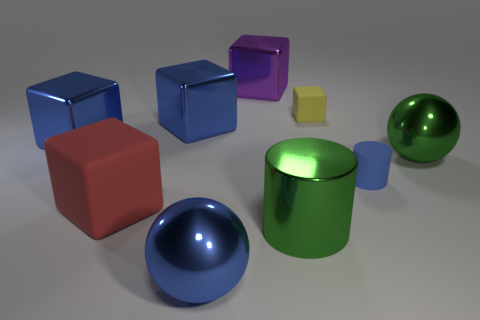Subtract all red cubes. How many cubes are left? 4 Subtract 1 cubes. How many cubes are left? 4 Subtract all cyan blocks. Subtract all cyan cylinders. How many blocks are left? 5 Add 1 tiny gray shiny spheres. How many objects exist? 10 Subtract all cubes. How many objects are left? 4 Subtract all purple blocks. Subtract all large purple metallic things. How many objects are left? 7 Add 7 green shiny cylinders. How many green shiny cylinders are left? 8 Add 4 big blue objects. How many big blue objects exist? 7 Subtract 0 cyan blocks. How many objects are left? 9 